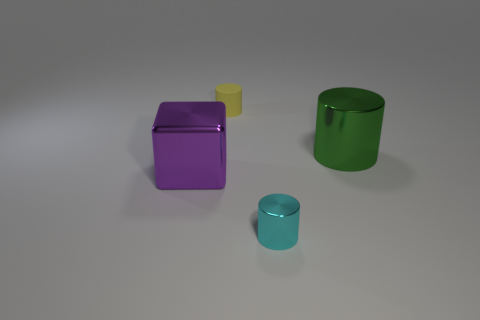Is the size of the metal cylinder that is in front of the purple block the same as the shiny thing left of the small yellow matte cylinder? No, the size of the metal cylinder in front of the purple block is not the same as the shiny thing to the left of the small yellow matte cylinder. The metal cylinder appears to be larger and has a different height and diameter compared to the shiny object. 